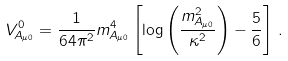Convert formula to latex. <formula><loc_0><loc_0><loc_500><loc_500>V ^ { 0 } _ { A _ { \mu 0 } } = \frac { 1 } { 6 4 \pi ^ { 2 } } m _ { A _ { \mu 0 } } ^ { 4 } \left [ \log \left ( \frac { m _ { A _ { \mu 0 } } ^ { 2 } } { \kappa ^ { 2 } } \right ) - \frac { 5 } { 6 } \right ] \, .</formula> 